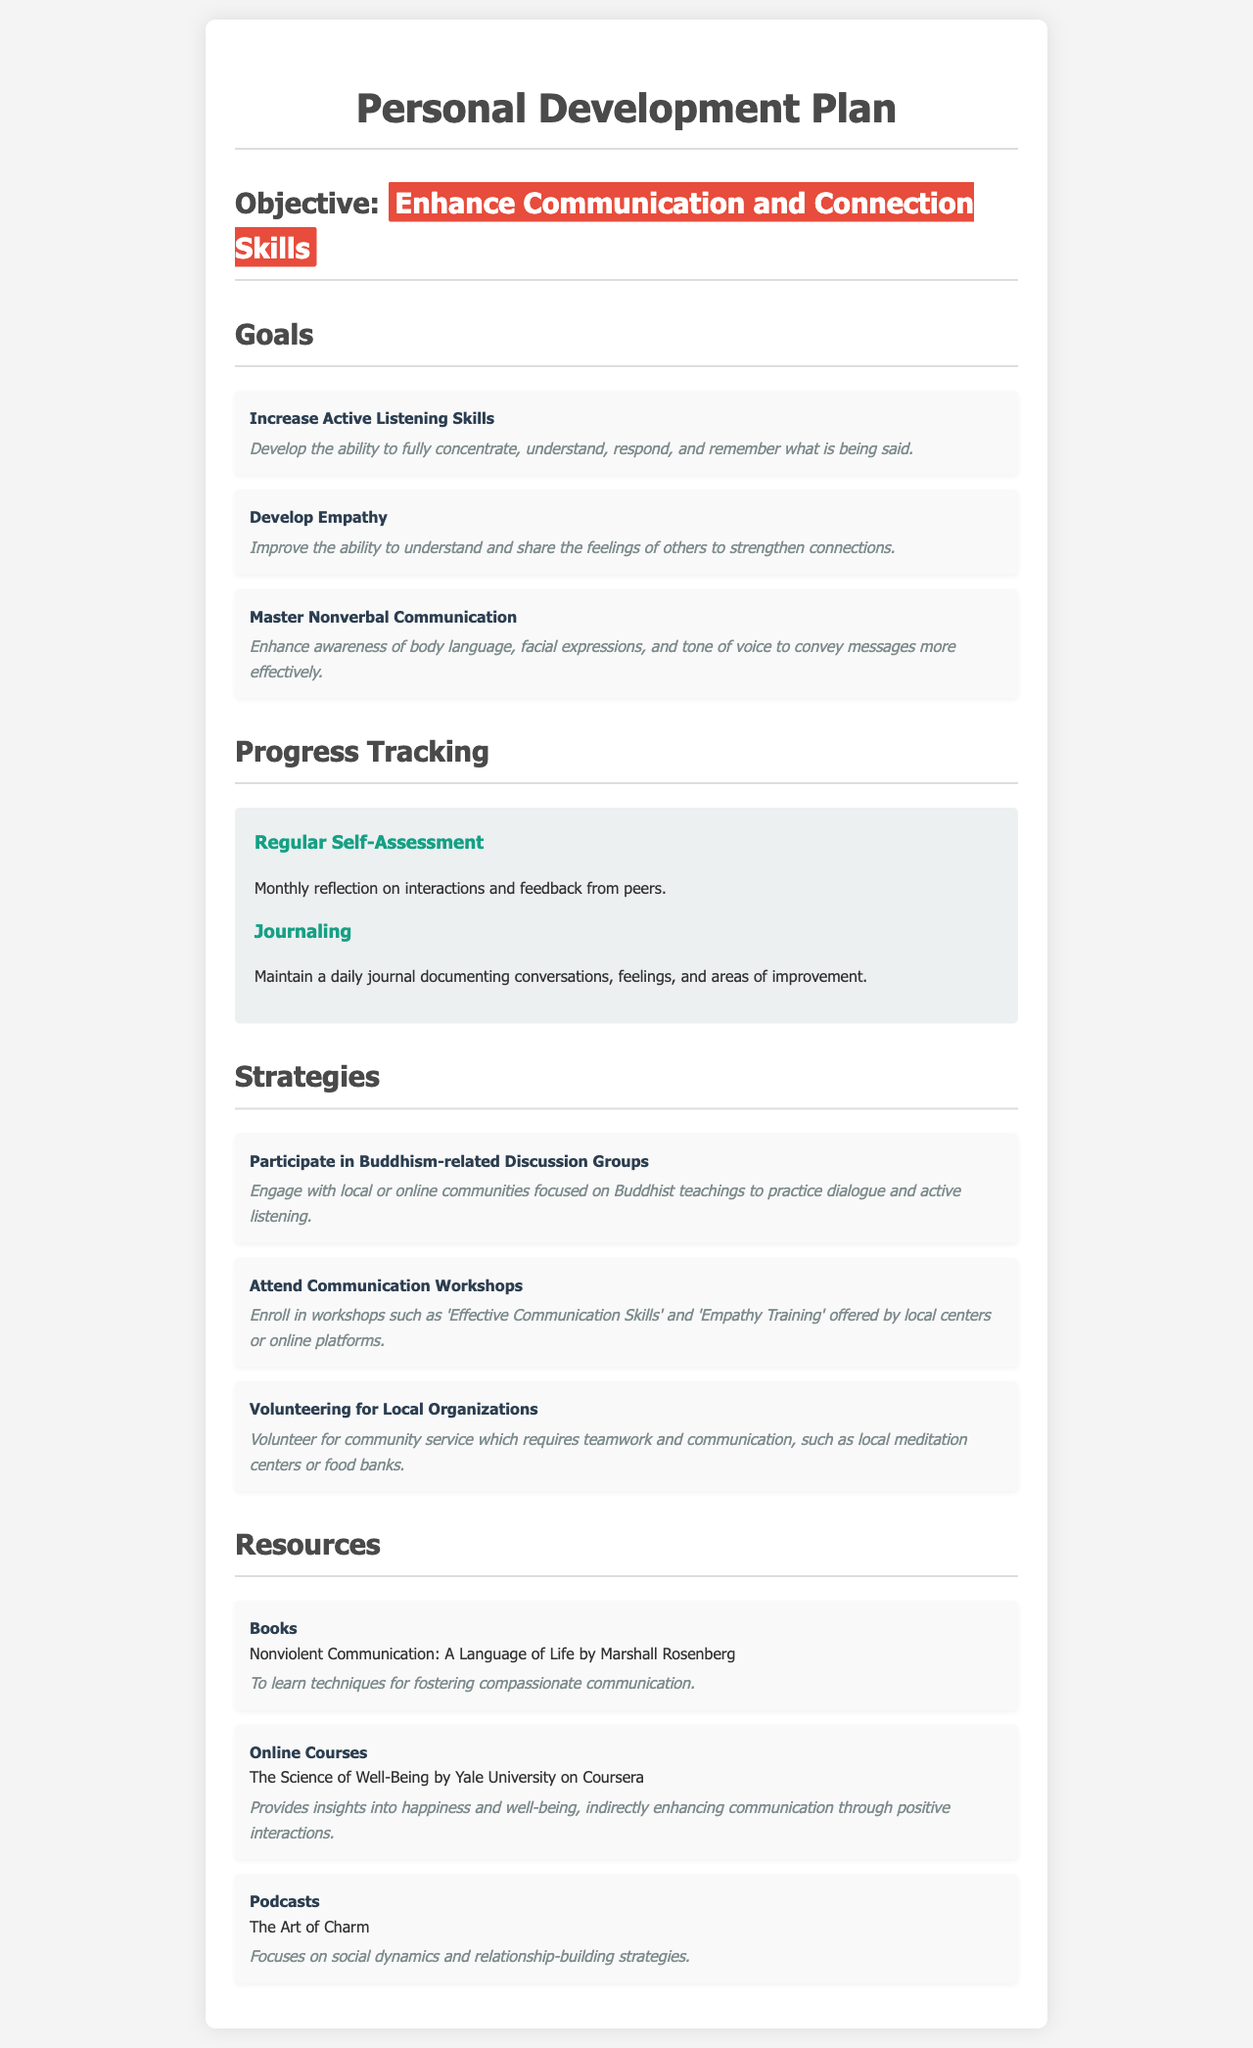What is the primary objective of the plan? The objective is to enhance communication and connection skills as stated in the document.
Answer: Enhance Communication and Connection Skills How many goals are outlined in the document? The document lists three specific goals under the 'Goals' section.
Answer: 3 What is one of the strategies mentioned for improving communication? The document includes several strategies, one of which is to participate in Buddhism-related discussion groups.
Answer: Participate in Buddhism-related Discussion Groups What resource type is 'Nonviolent Communication: A Language of Life'? The document categorizes it under the resource type 'Books'.
Answer: Books How often should self-assessment be conducted according to the plan? The document indicates that self-assessment should be conducted monthly.
Answer: Monthly What is one way to track progress mentioned in the document? The document suggests maintaining a daily journal to document conversations and feelings.
Answer: Journaling Which online course is recommended in the resources? The course mentioned in the document is 'The Science of Well-Being by Yale University on Coursera'.
Answer: The Science of Well-Being by Yale University on Coursera What is the main focus of the podcast 'The Art of Charm'? The podcast is centered around social dynamics and relationship-building strategies.
Answer: Social dynamics and relationship-building strategies What specific skill does the goal of 'Master Nonverbal Communication' target? The goal specifically targets the awareness of body language, facial expressions, and tone of voice.
Answer: Awareness of body language, facial expressions, and tone of voice 